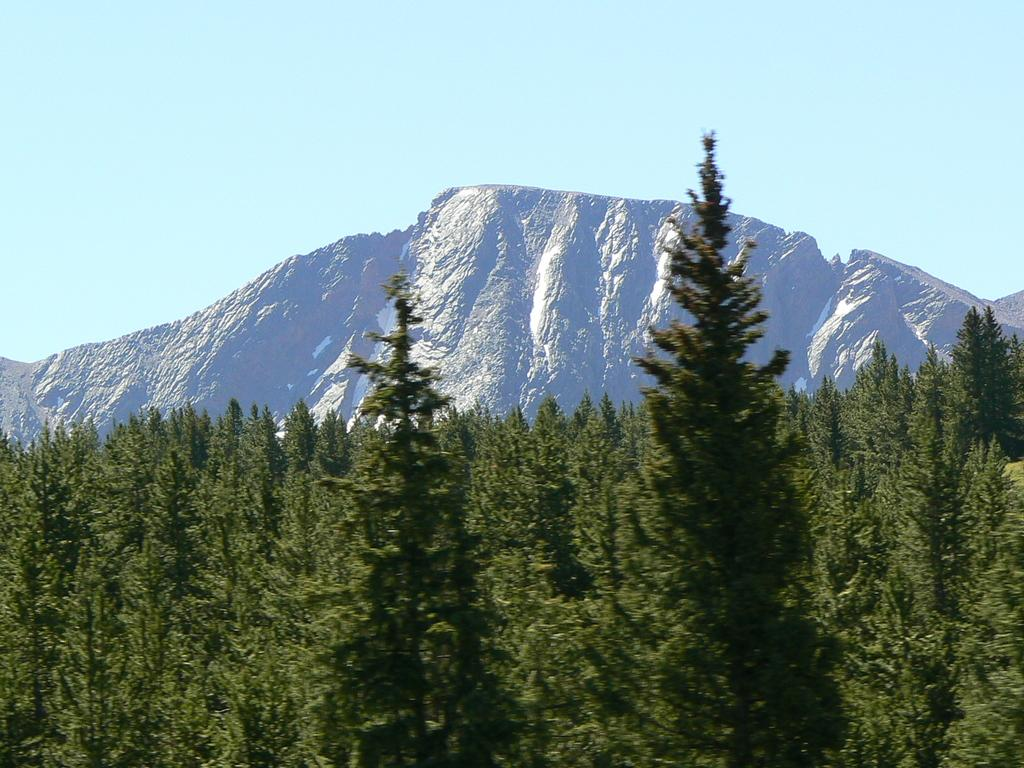What type of vegetation can be seen in the image? There are trees in the image. What geographical features are visible in the image? There are hills visible in the image. What part of the natural environment is visible in the image? The sky is visible in the image. How many cacti can be seen in the image? There are no cacti present in the image; it features trees and hills. What type of weather event is occurring in the image? There is no indication of a rainstorm or any specific weather event in the image; it simply shows trees, hills, and the sky. 